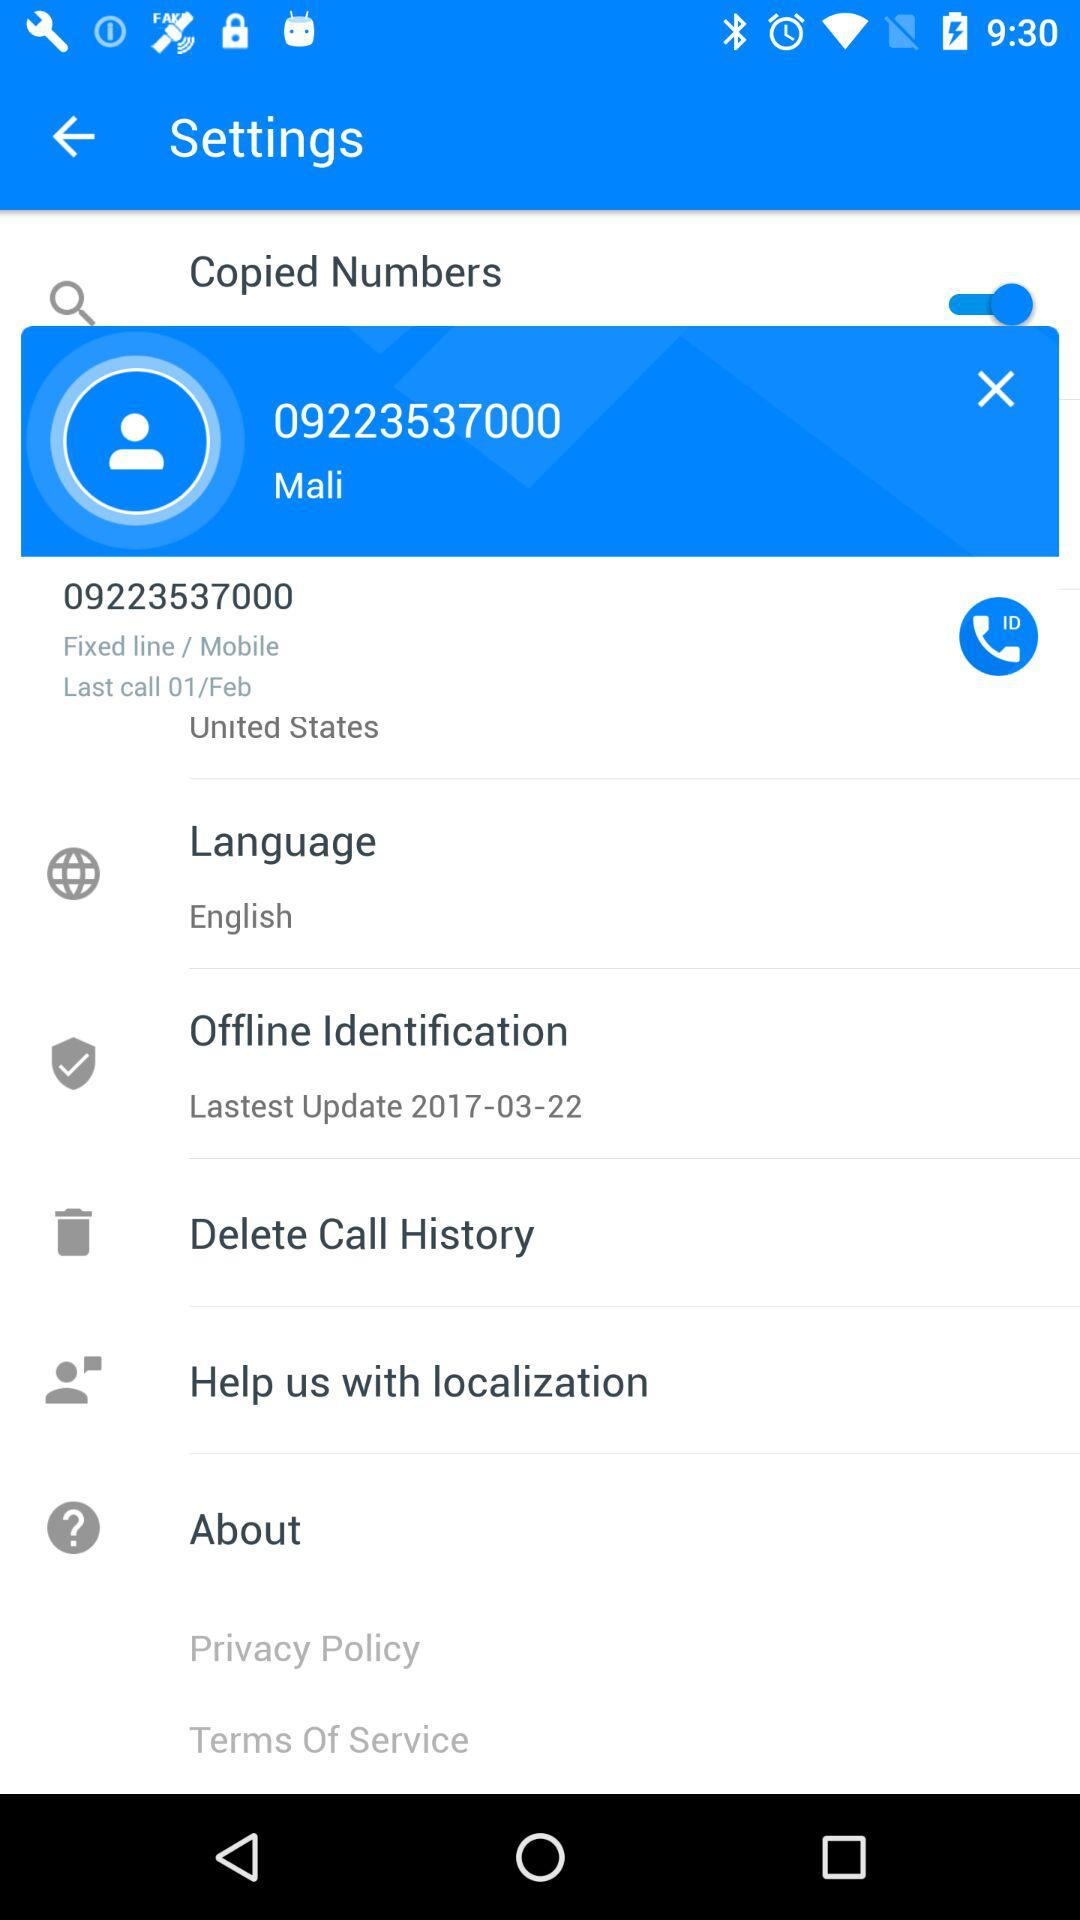When was the offline identification last updated? It was last updated on March 22, 2017. 